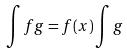Convert formula to latex. <formula><loc_0><loc_0><loc_500><loc_500>\int f g = f ( x ) \int g</formula> 